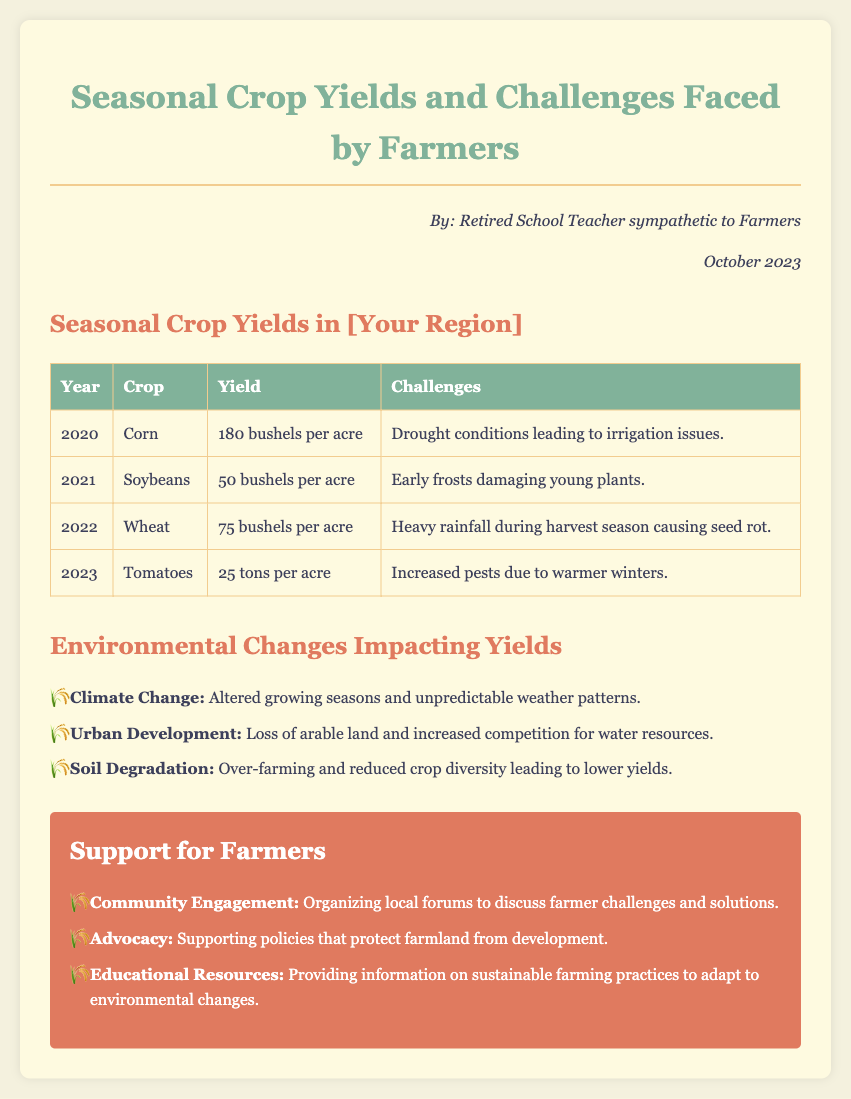What is the highest crop yield listed for 2020? The document states that the yield for corn in 2020 was 180 bushels per acre, which is the highest yield mentioned.
Answer: 180 bushels per acre What crop had the lowest yield in 2023? In 2023, the document indicates that tomatoes had a yield of 25 tons per acre, which is the lowest yield compared to other crops listed.
Answer: 25 tons per acre What were the challenges faced by farmers in 2021? According to the memo, farmers faced early frosts that damaged young soybean plants in 2021.
Answer: Early frosts Which crop's yield decreased significantly from 2020 to 2023? The document shows that tomato yields in 2023 (25 tons per acre) decreased significantly compared to corn in 2020 (180 bushels per acre).
Answer: Tomatoes What environmental change is noted as impacting yields? The document lists climate change as one of the environmental changes impacting crop yields.
Answer: Climate Change What is one suggested way to support farmers? The memo suggests organizing local forums as a way to support farmers in addressing their challenges.
Answer: Community Engagement What year did heavy rainfall during harvest cause issues for wheat? The document states that heavy rainfall caused problems for wheat during the harvest season in 2022.
Answer: 2022 How many challenges are mentioned under environmental changes? The document outlines three challenges related to environmental changes impacting yields.
Answer: Three 